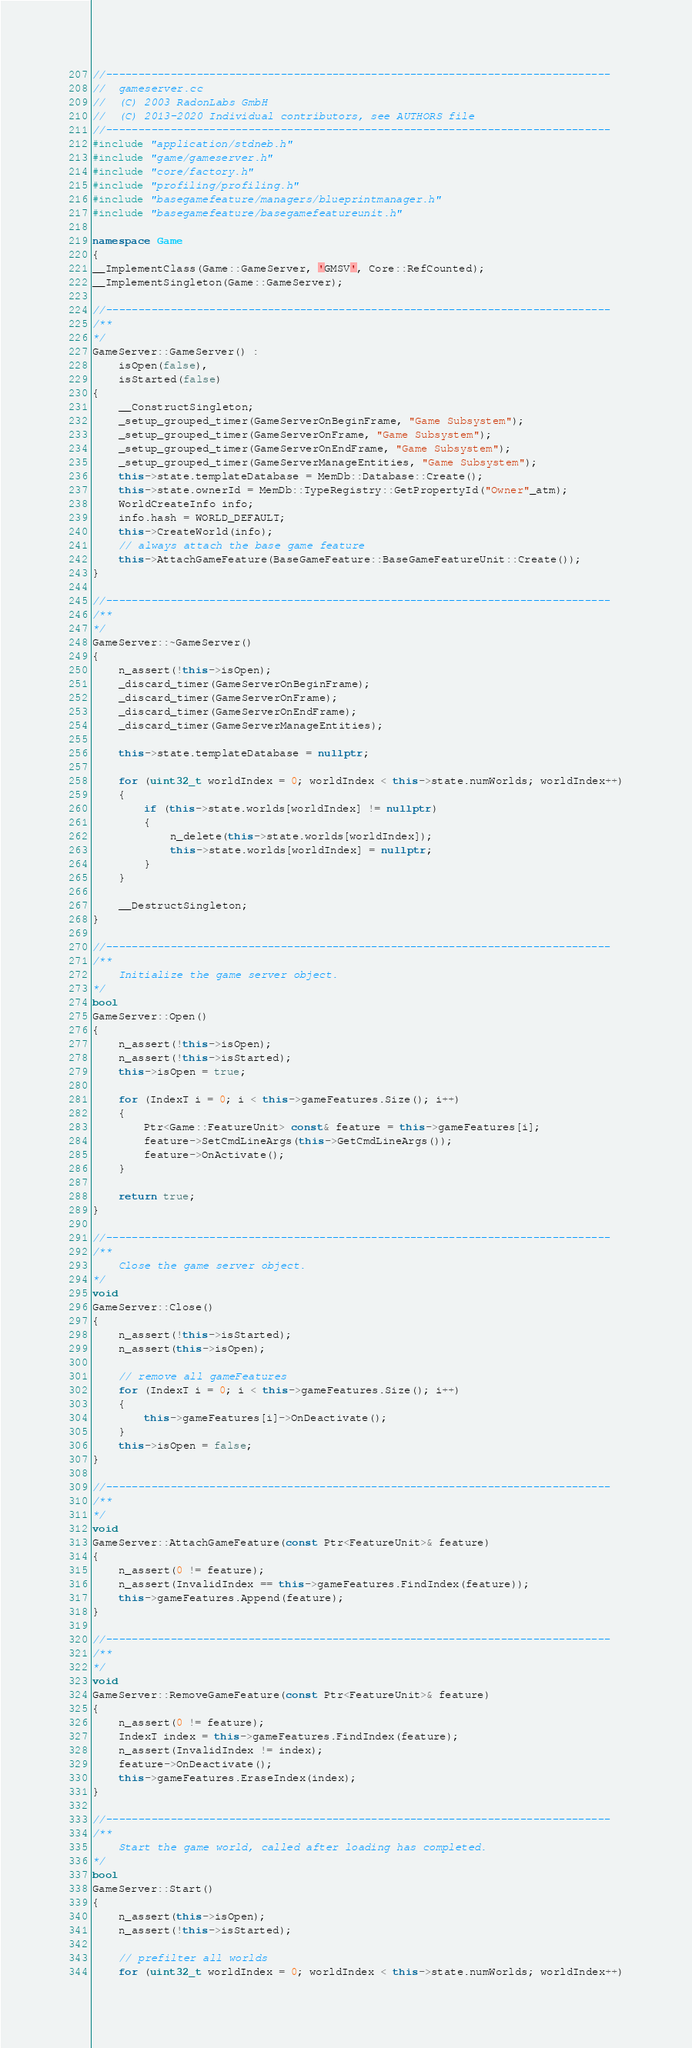<code> <loc_0><loc_0><loc_500><loc_500><_C++_>//------------------------------------------------------------------------------
//  gameserver.cc
//  (C) 2003 RadonLabs GmbH
//  (C) 2013-2020 Individual contributors, see AUTHORS file
//------------------------------------------------------------------------------
#include "application/stdneb.h"
#include "game/gameserver.h"
#include "core/factory.h"
#include "profiling/profiling.h"
#include "basegamefeature/managers/blueprintmanager.h"
#include "basegamefeature/basegamefeatureunit.h"

namespace Game
{
__ImplementClass(Game::GameServer, 'GMSV', Core::RefCounted);
__ImplementSingleton(Game::GameServer);

//------------------------------------------------------------------------------
/**
*/
GameServer::GameServer() :
    isOpen(false),
    isStarted(false)
{
    __ConstructSingleton;
    _setup_grouped_timer(GameServerOnBeginFrame, "Game Subsystem");
    _setup_grouped_timer(GameServerOnFrame, "Game Subsystem");
    _setup_grouped_timer(GameServerOnEndFrame, "Game Subsystem");
    _setup_grouped_timer(GameServerManageEntities, "Game Subsystem");
    this->state.templateDatabase = MemDb::Database::Create();
    this->state.ownerId = MemDb::TypeRegistry::GetPropertyId("Owner"_atm);
    WorldCreateInfo info;
    info.hash = WORLD_DEFAULT;
    this->CreateWorld(info);
    // always attach the base game feature
    this->AttachGameFeature(BaseGameFeature::BaseGameFeatureUnit::Create());
}

//------------------------------------------------------------------------------
/**
*/
GameServer::~GameServer()
{
    n_assert(!this->isOpen);
    _discard_timer(GameServerOnBeginFrame);
    _discard_timer(GameServerOnFrame);
    _discard_timer(GameServerOnEndFrame);
    _discard_timer(GameServerManageEntities);

    this->state.templateDatabase = nullptr;

    for (uint32_t worldIndex = 0; worldIndex < this->state.numWorlds; worldIndex++)
    {
        if (this->state.worlds[worldIndex] != nullptr)
        {
            n_delete(this->state.worlds[worldIndex]);
            this->state.worlds[worldIndex] = nullptr;
        }
    }

    __DestructSingleton;
}

//------------------------------------------------------------------------------
/**
    Initialize the game server object.
*/
bool
GameServer::Open()
{
    n_assert(!this->isOpen);
    n_assert(!this->isStarted);
    this->isOpen = true;

    for (IndexT i = 0; i < this->gameFeatures.Size(); i++)
    {
        Ptr<Game::FeatureUnit> const& feature = this->gameFeatures[i];
        feature->SetCmdLineArgs(this->GetCmdLineArgs());
        feature->OnActivate();
    }

    return true;
}

//------------------------------------------------------------------------------
/**
    Close the game server object.
*/
void
GameServer::Close()
{
    n_assert(!this->isStarted);
    n_assert(this->isOpen);

    // remove all gameFeatures
    for (IndexT i = 0; i < this->gameFeatures.Size(); i++)
    {
        this->gameFeatures[i]->OnDeactivate();
    }
    this->isOpen = false;
}

//------------------------------------------------------------------------------
/**
*/
void
GameServer::AttachGameFeature(const Ptr<FeatureUnit>& feature)
{
    n_assert(0 != feature);
    n_assert(InvalidIndex == this->gameFeatures.FindIndex(feature));
    this->gameFeatures.Append(feature);
}

//------------------------------------------------------------------------------
/**
*/
void
GameServer::RemoveGameFeature(const Ptr<FeatureUnit>& feature)
{
    n_assert(0 != feature);
    IndexT index = this->gameFeatures.FindIndex(feature);
    n_assert(InvalidIndex != index);
    feature->OnDeactivate();
    this->gameFeatures.EraseIndex(index);
}

//------------------------------------------------------------------------------
/**
    Start the game world, called after loading has completed.
*/
bool
GameServer::Start()
{
    n_assert(this->isOpen);
    n_assert(!this->isStarted);

	// prefilter all worlds
	for (uint32_t worldIndex = 0; worldIndex < this->state.numWorlds; worldIndex++)</code> 